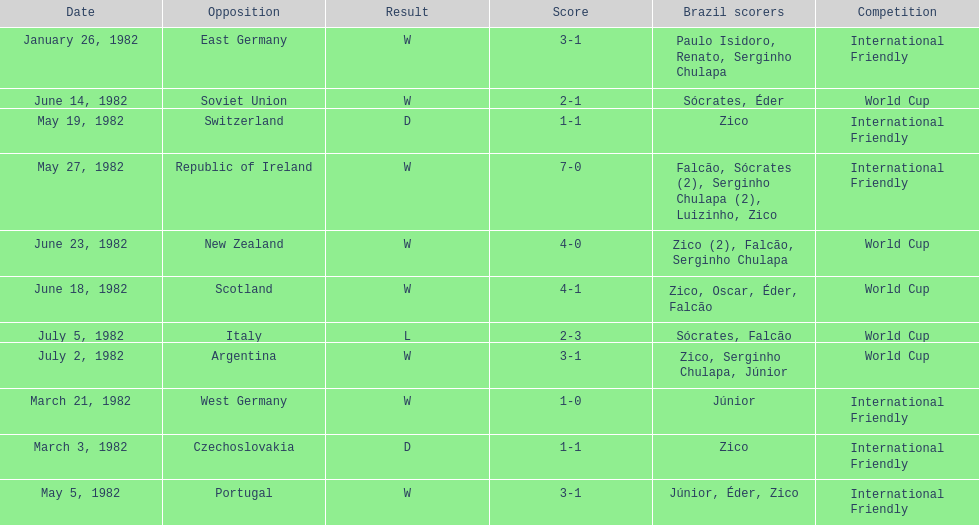How many games did zico end up scoring in during this season? 7. 